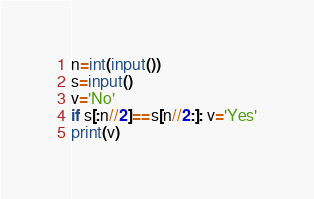Convert code to text. <code><loc_0><loc_0><loc_500><loc_500><_Python_>n=int(input())
s=input()
v='No'
if s[:n//2]==s[n//2:]: v='Yes'
print(v)
</code> 